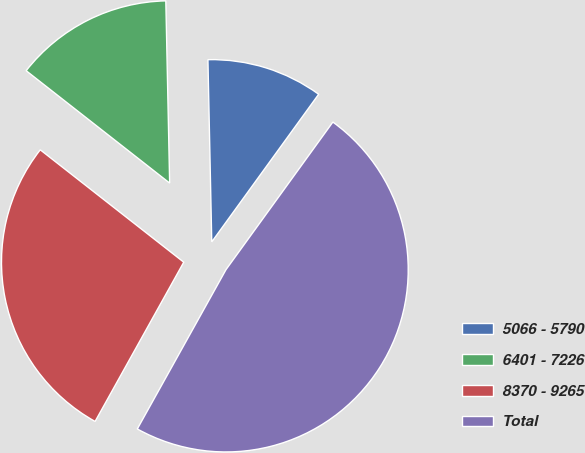Convert chart. <chart><loc_0><loc_0><loc_500><loc_500><pie_chart><fcel>5066 - 5790<fcel>6401 - 7226<fcel>8370 - 9265<fcel>Total<nl><fcel>10.31%<fcel>14.09%<fcel>27.49%<fcel>48.11%<nl></chart> 